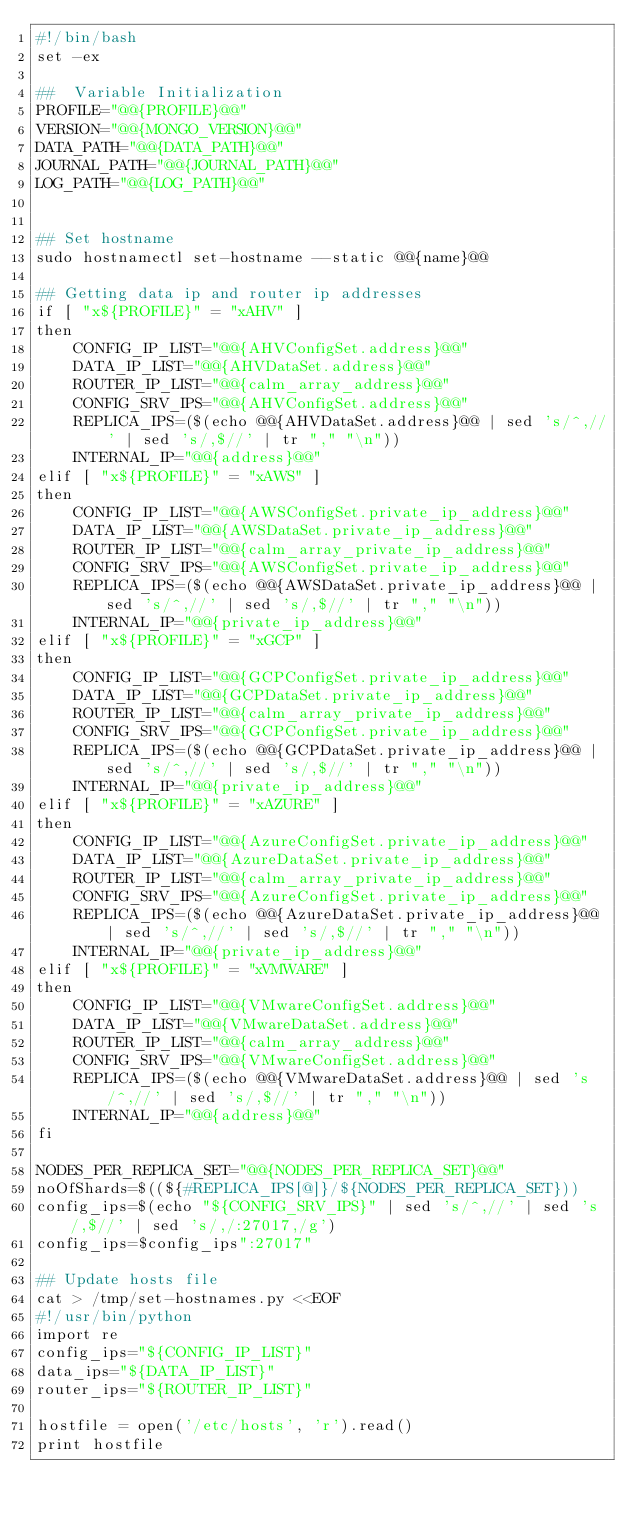<code> <loc_0><loc_0><loc_500><loc_500><_Bash_>#!/bin/bash
set -ex

##  Variable Initialization
PROFILE="@@{PROFILE}@@"
VERSION="@@{MONGO_VERSION}@@"
DATA_PATH="@@{DATA_PATH}@@"
JOURNAL_PATH="@@{JOURNAL_PATH}@@"
LOG_PATH="@@{LOG_PATH}@@"


## Set hostname
sudo hostnamectl set-hostname --static @@{name}@@

## Getting data ip and router ip addresses
if [ "x${PROFILE}" = "xAHV" ]
then
    CONFIG_IP_LIST="@@{AHVConfigSet.address}@@"
    DATA_IP_LIST="@@{AHVDataSet.address}@@"
    ROUTER_IP_LIST="@@{calm_array_address}@@"
    CONFIG_SRV_IPS="@@{AHVConfigSet.address}@@"
    REPLICA_IPS=($(echo @@{AHVDataSet.address}@@ | sed 's/^,//' | sed 's/,$//' | tr "," "\n"))
    INTERNAL_IP="@@{address}@@"
elif [ "x${PROFILE}" = "xAWS" ]
then
    CONFIG_IP_LIST="@@{AWSConfigSet.private_ip_address}@@"
    DATA_IP_LIST="@@{AWSDataSet.private_ip_address}@@"
    ROUTER_IP_LIST="@@{calm_array_private_ip_address}@@"
    CONFIG_SRV_IPS="@@{AWSConfigSet.private_ip_address}@@"
    REPLICA_IPS=($(echo @@{AWSDataSet.private_ip_address}@@ | sed 's/^,//' | sed 's/,$//' | tr "," "\n"))
    INTERNAL_IP="@@{private_ip_address}@@"    
elif [ "x${PROFILE}" = "xGCP" ]
then
    CONFIG_IP_LIST="@@{GCPConfigSet.private_ip_address}@@"
    DATA_IP_LIST="@@{GCPDataSet.private_ip_address}@@" 
    ROUTER_IP_LIST="@@{calm_array_private_ip_address}@@"
    CONFIG_SRV_IPS="@@{GCPConfigSet.private_ip_address}@@"
    REPLICA_IPS=($(echo @@{GCPDataSet.private_ip_address}@@ | sed 's/^,//' | sed 's/,$//' | tr "," "\n"))
    INTERNAL_IP="@@{private_ip_address}@@"    
elif [ "x${PROFILE}" = "xAZURE" ]
then
    CONFIG_IP_LIST="@@{AzureConfigSet.private_ip_address}@@"
    DATA_IP_LIST="@@{AzureDataSet.private_ip_address}@@" 
    ROUTER_IP_LIST="@@{calm_array_private_ip_address}@@"
    CONFIG_SRV_IPS="@@{AzureConfigSet.private_ip_address}@@"
    REPLICA_IPS=($(echo @@{AzureDataSet.private_ip_address}@@ | sed 's/^,//' | sed 's/,$//' | tr "," "\n"))
    INTERNAL_IP="@@{private_ip_address}@@"    
elif [ "x${PROFILE}" = "xVMWARE" ]
then
    CONFIG_IP_LIST="@@{VMwareConfigSet.address}@@"
    DATA_IP_LIST="@@{VMwareDataSet.address}@@" 
    ROUTER_IP_LIST="@@{calm_array_address}@@"
    CONFIG_SRV_IPS="@@{VMwareConfigSet.address}@@"
    REPLICA_IPS=($(echo @@{VMwareDataSet.address}@@ | sed 's/^,//' | sed 's/,$//' | tr "," "\n"))
    INTERNAL_IP="@@{address}@@"    
fi

NODES_PER_REPLICA_SET="@@{NODES_PER_REPLICA_SET}@@"
noOfShards=$((${#REPLICA_IPS[@]}/${NODES_PER_REPLICA_SET}))
config_ips=$(echo "${CONFIG_SRV_IPS}" | sed 's/^,//' | sed 's/,$//' | sed 's/,/:27017,/g')
config_ips=$config_ips":27017"

## Update hosts file 
cat > /tmp/set-hostnames.py <<EOF
#!/usr/bin/python
import re
config_ips="${CONFIG_IP_LIST}"
data_ips="${DATA_IP_LIST}"
router_ips="${ROUTER_IP_LIST}"

hostfile = open('/etc/hosts', 'r').read()
print hostfile</code> 